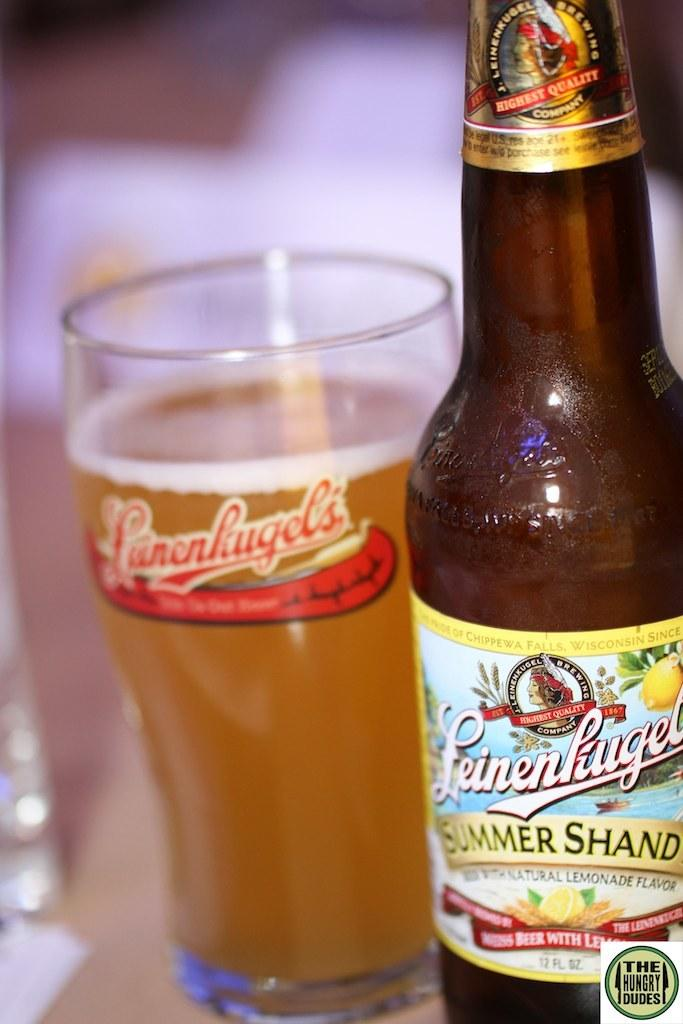<image>
Write a terse but informative summary of the picture. A bottle of Summer Shandy has been poured into a glass 